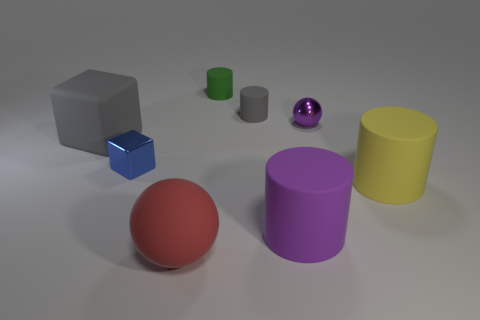Subtract all big yellow cylinders. How many cylinders are left? 3 Subtract all purple cylinders. How many cylinders are left? 3 Add 1 big gray blocks. How many objects exist? 9 Subtract all balls. How many objects are left? 6 Subtract all blue cylinders. Subtract all brown cubes. How many cylinders are left? 4 Add 4 purple metallic spheres. How many purple metallic spheres exist? 5 Subtract 1 gray cylinders. How many objects are left? 7 Subtract all small things. Subtract all big brown cubes. How many objects are left? 4 Add 5 tiny green objects. How many tiny green objects are left? 6 